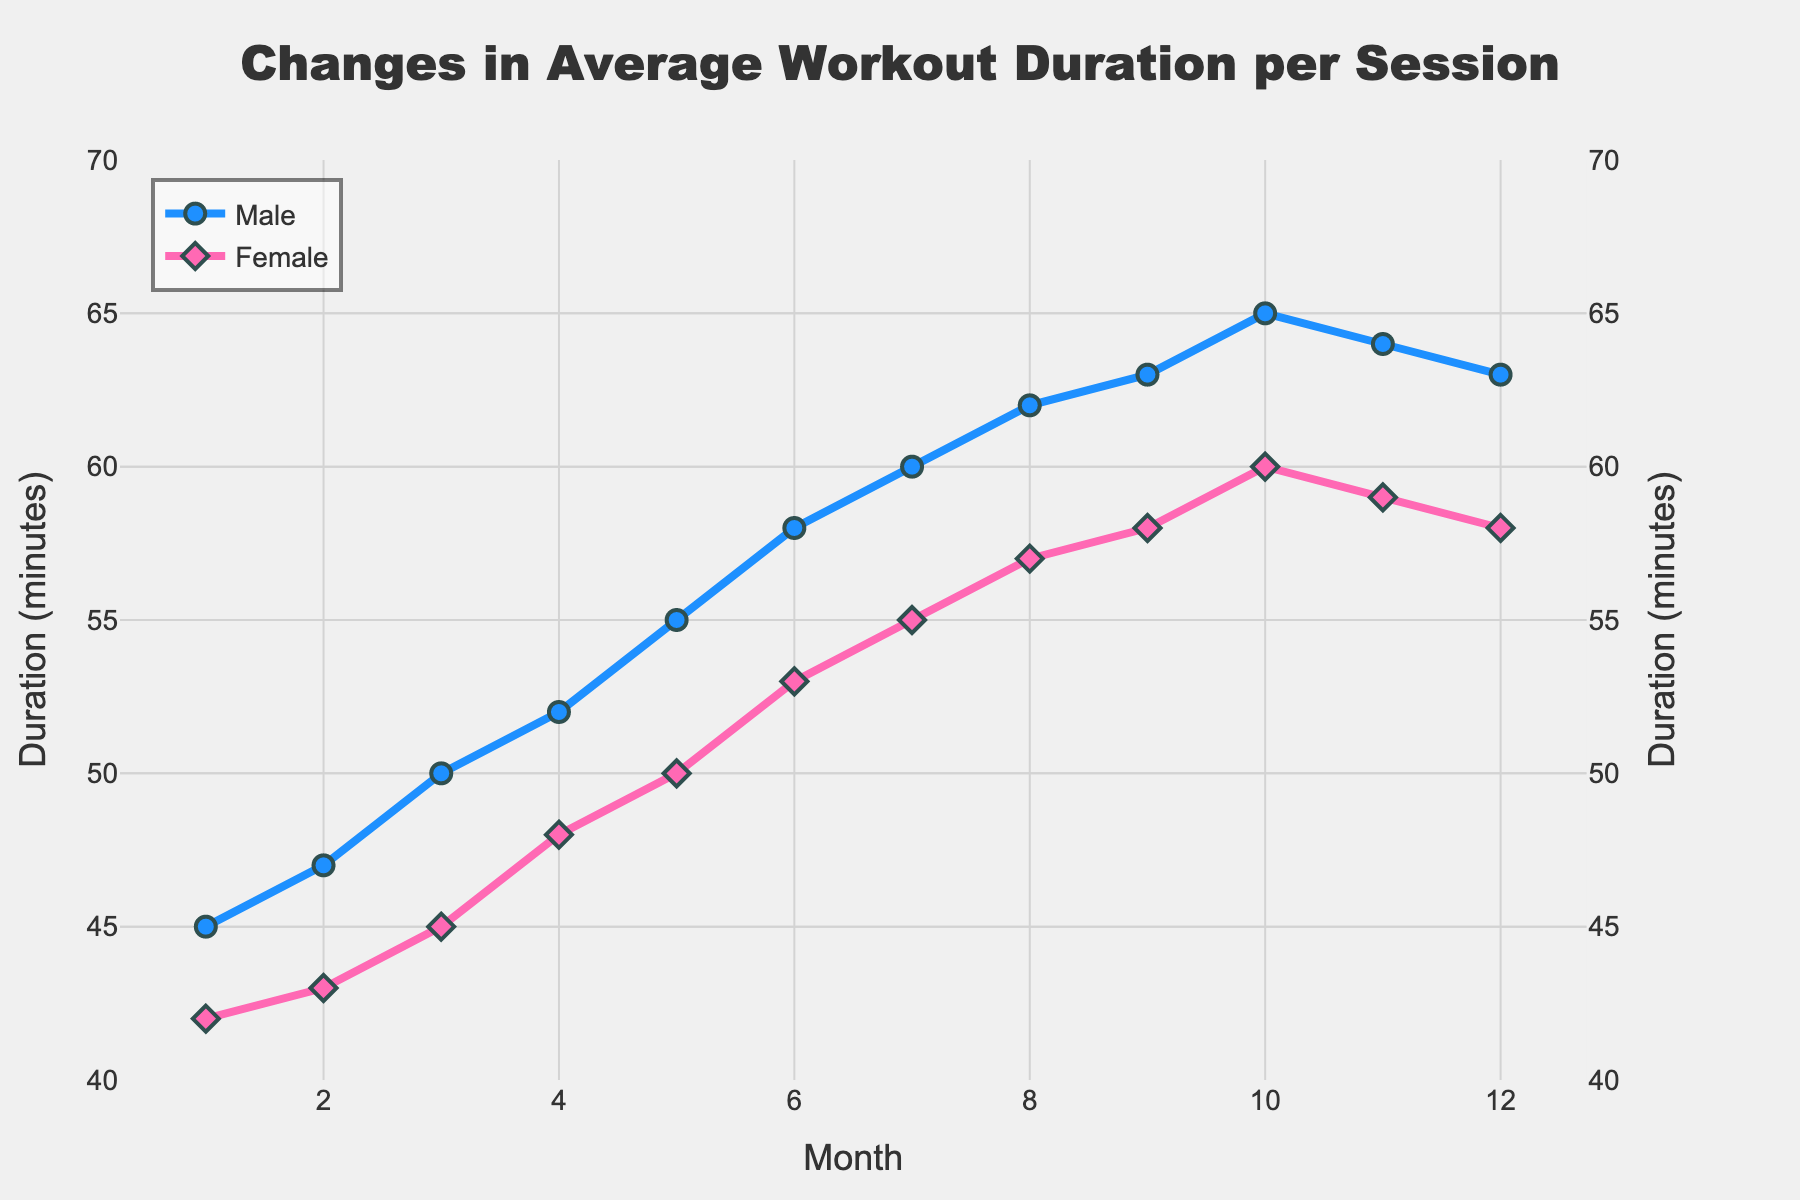What month had the highest average workout duration for male members? The figure shows the average workout duration per session for each month. By looking at the line representing male members, the highest point occurs at the 10th month.
Answer: Month 10 By how many minutes did the workout duration for female members increase from Month 1 to Month 12? Subtract the average duration in Month 1 from that in Month 12 for female members. Month 1 is 42 minutes and Month 12 is 58 minutes. 58 - 42 = 16 minutes.
Answer: 16 minutes What is the difference between the average workout duration of male and female members in the 7th month? Find the average duration for both male and female members in Month 7, then subtract the female duration from the male duration. Male: 60 minutes, Female: 55 minutes. 60 - 55 = 5 minutes.
Answer: 5 minutes Which gender experienced a greater increase in average workout duration from Month 1 to Month 6? Calculate the increase over the period for both genders. Male: 58 (Month 6) - 45 (Month 1) = 13 minutes. Female: 53 (Month 6) - 42 (Month 1) = 11 minutes. Male members experienced a greater increase.
Answer: Male Did the average workout duration for both genders increase, decrease, or remain the same from Month 11 to Month 12? Check the average workout durations in Months 11 and 12 for both genders. Male: 64 (Month 11) to 63 (Month 12) indicates a decrease. Female: 59 (Month 11) to 58 (Month 12) also indicates a decrease. Both durations decreased.
Answer: Decrease From which month to which month did male members see the largest increase in average workout duration? Analyze the month-to-month differences for male members and identify the period with the largest increase. The largest increase is from 4th month (52 minutes) to the 5th month (55 minutes), which is an increase of 3 minutes.
Answer: Month 4 to Month 5 What month had the smallest difference between the average workout durations of male and female members? Calculate the differences month by month and find the month with the smallest difference. Month 12 has the smallest difference with Male: 63 - Female: 58 = 5 minutes.
Answer: Month 12 What is the overall trend in the average workout duration for female members from Month 1 to Month 12? Observe the line representing female members over the months. The duration consistently increases from Month 1 to Month 10 and slightly drops in the last two months, suggesting an overall upward trend followed by a slight decline.
Answer: Upward trend with slight decline at the end How many minutes did the average workout duration differ between the highest and lowest points for female members throughout the year? Identify the highest and lowest points for female members. The highest is in Month 10 (60 minutes) and the lowest is in Month 1 (42 minutes). The difference is 60 - 42 = 18 minutes.
Answer: 18 minutes 